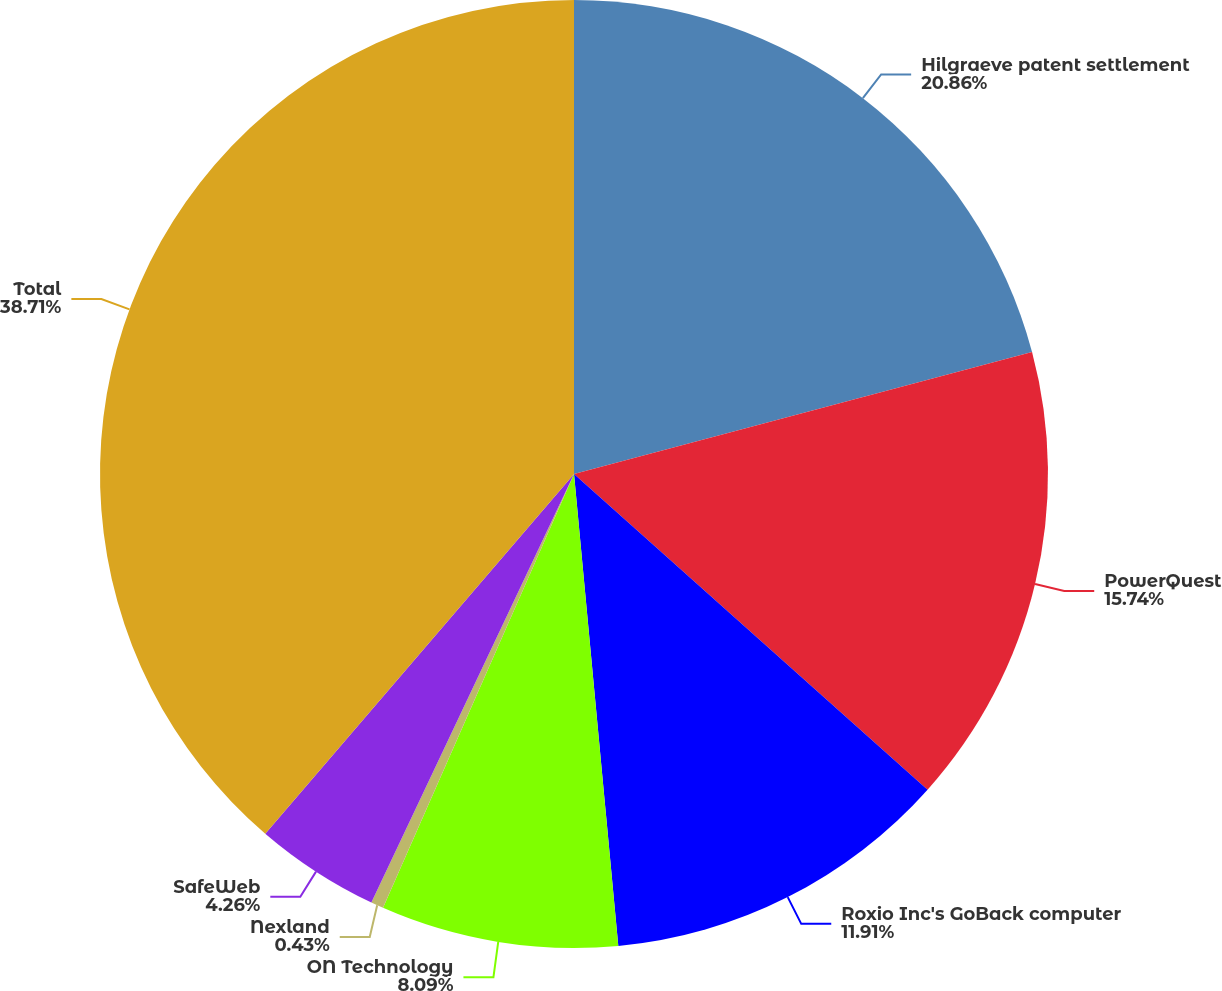Convert chart to OTSL. <chart><loc_0><loc_0><loc_500><loc_500><pie_chart><fcel>Hilgraeve patent settlement<fcel>PowerQuest<fcel>Roxio Inc's GoBack computer<fcel>ON Technology<fcel>Nexland<fcel>SafeWeb<fcel>Total<nl><fcel>20.86%<fcel>15.74%<fcel>11.91%<fcel>8.09%<fcel>0.43%<fcel>4.26%<fcel>38.71%<nl></chart> 